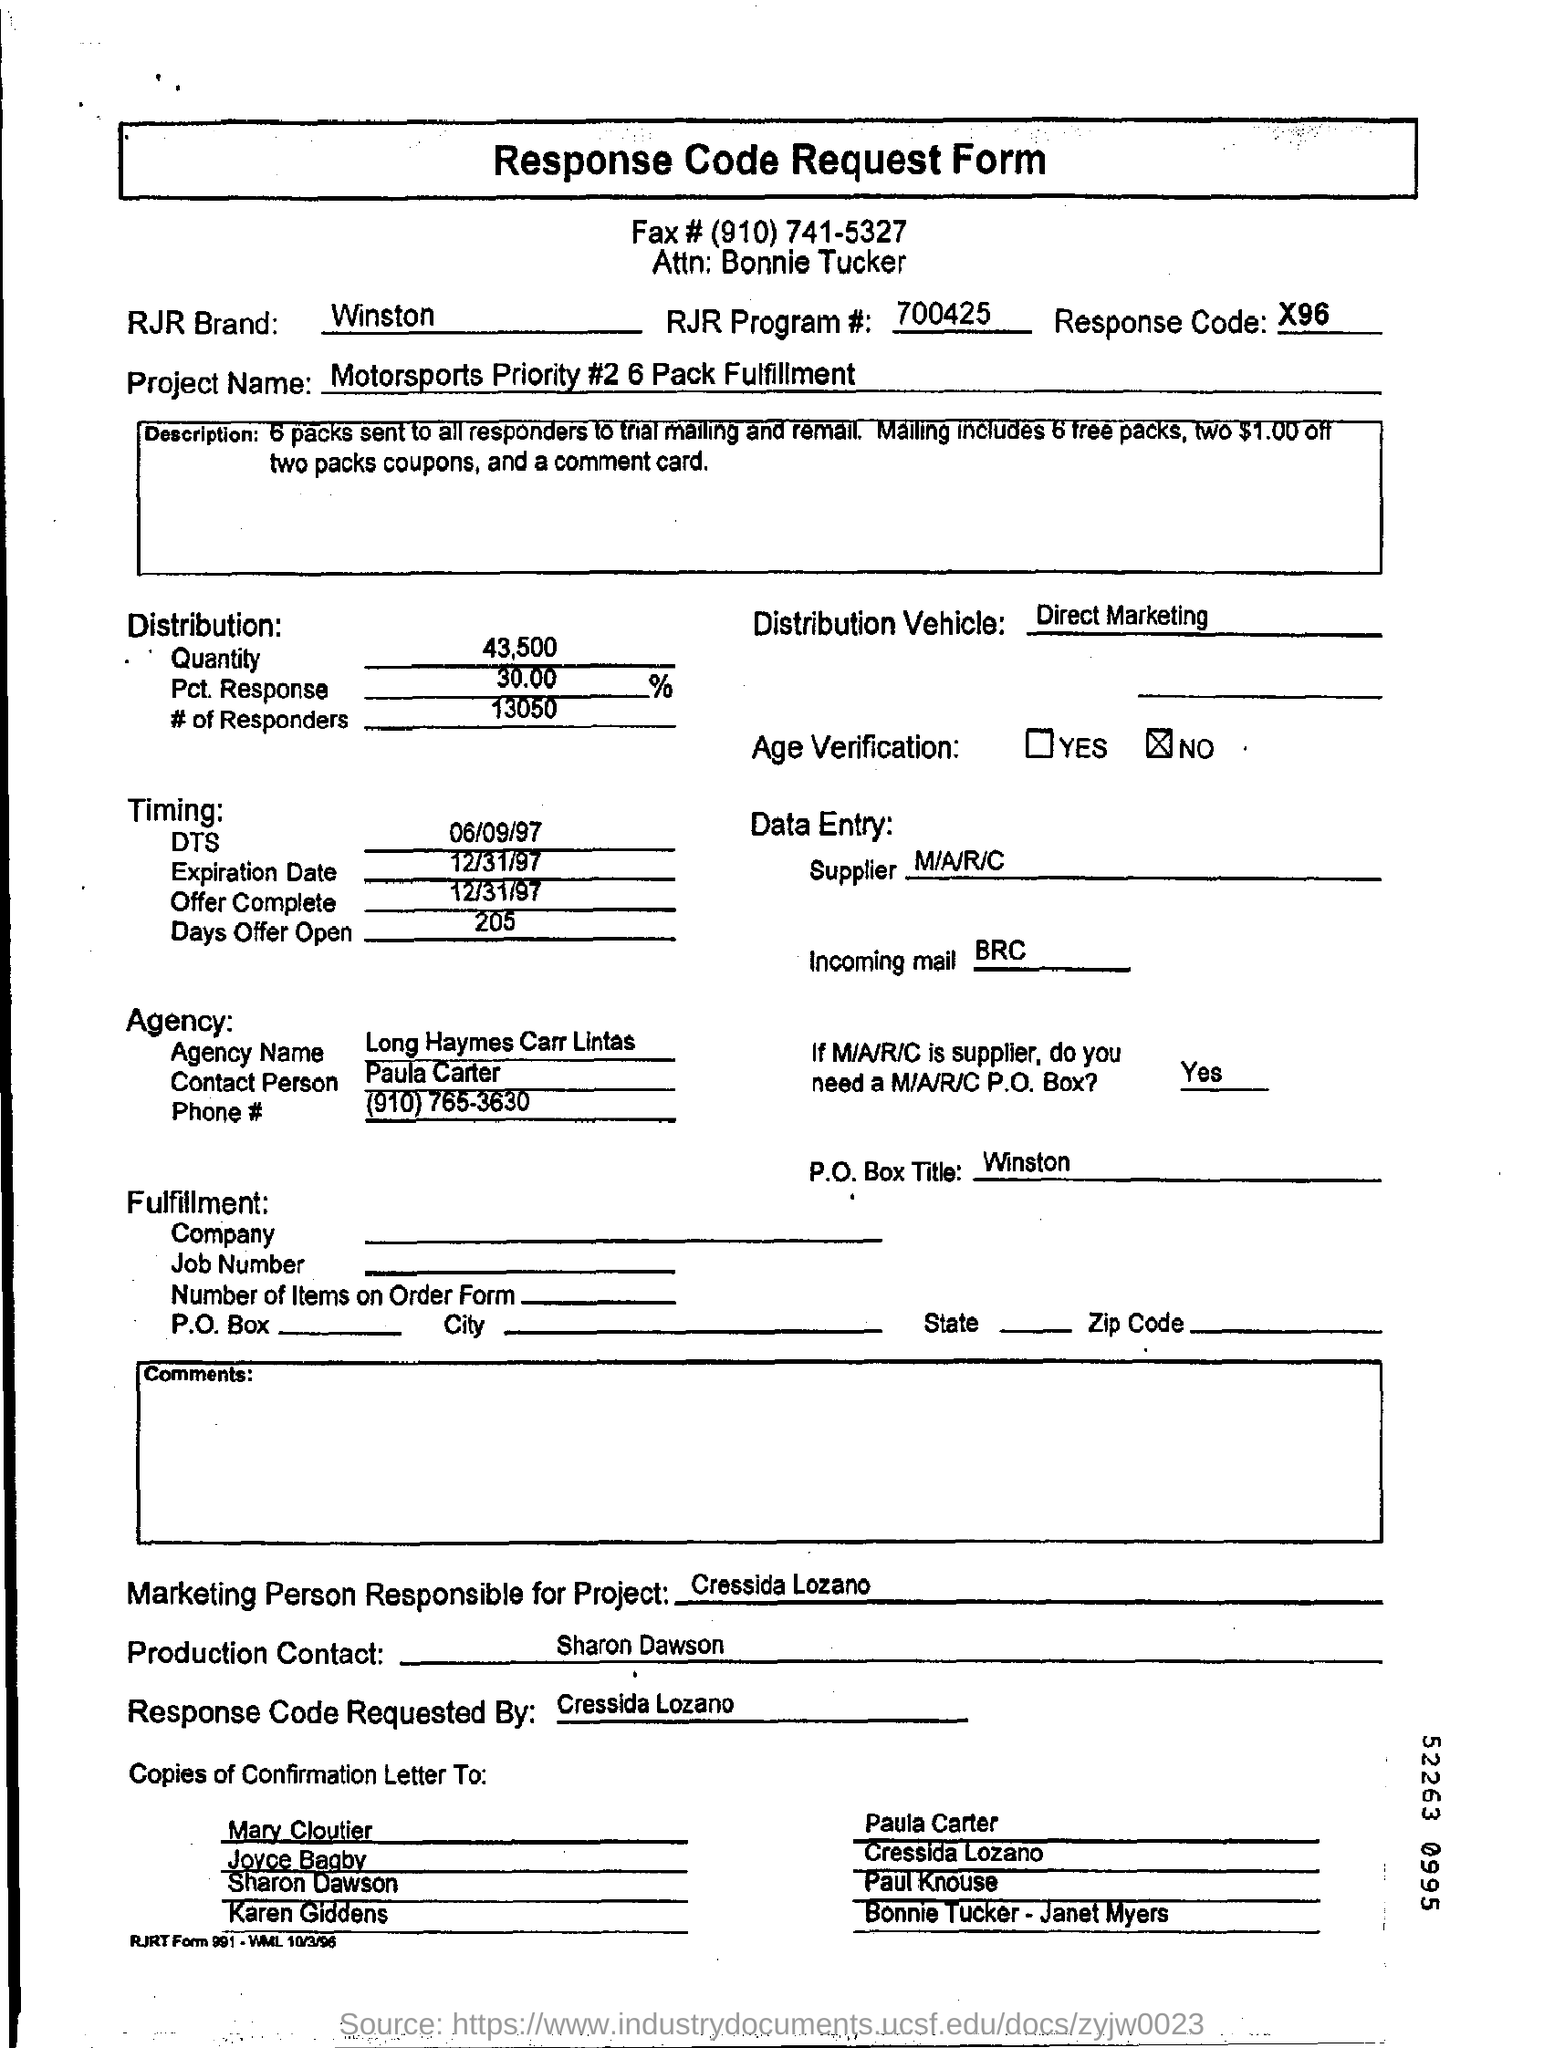Specify some key components in this picture. The "Project Name" is a priority that ranks second in importance to motorsports. Our goal is to fulfill a total of six packs. The brand in the document is named Winston. The response code is X96. This is a Declarative Sentence about a Response Code Request Form. What is the fax number provided at the top of the form? (910) 741-5327... 